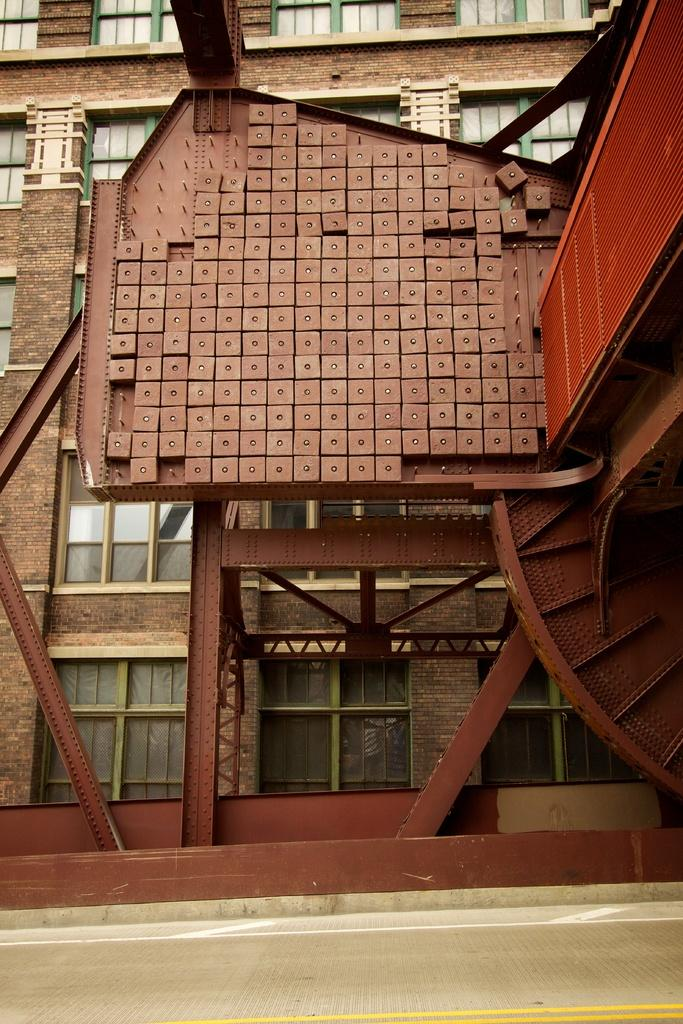What type of structure can be seen in the background of the image? There is a building in the background of the image. What is located on the right side of the image? There is a frame on the right side of the image. What can be seen in the foreground of the image? A road is visible in the image. What type of noise can be heard coming from the building in the image? There is no information about any noise in the image, so it cannot be determined from the image. 